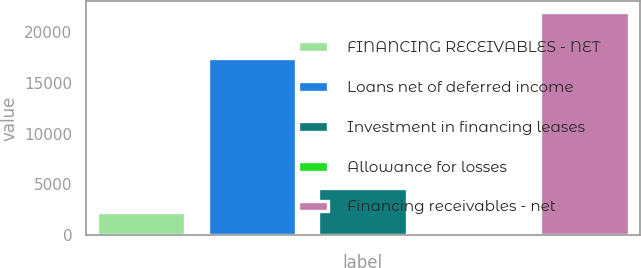Convert chart. <chart><loc_0><loc_0><loc_500><loc_500><bar_chart><fcel>FINANCING RECEIVABLES - NET<fcel>Loans net of deferred income<fcel>Investment in financing leases<fcel>Allowance for losses<fcel>Financing receivables - net<nl><fcel>2242.6<fcel>17404<fcel>4614<fcel>51<fcel>21967<nl></chart> 